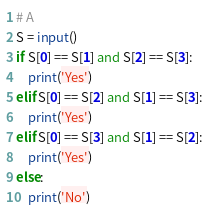Convert code to text. <code><loc_0><loc_0><loc_500><loc_500><_Python_># A
S = input()
if S[0] == S[1] and S[2] == S[3]:
    print('Yes')
elif S[0] == S[2] and S[1] == S[3]:
    print('Yes')
elif S[0] == S[3] and S[1] == S[2]:
    print('Yes')
else:
    print('No')</code> 